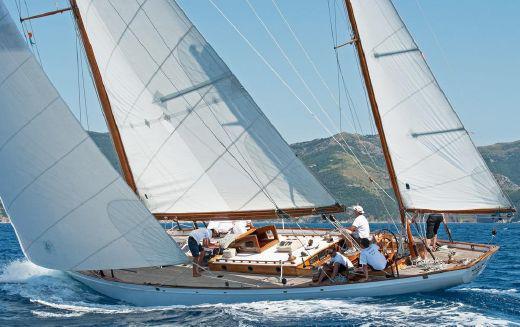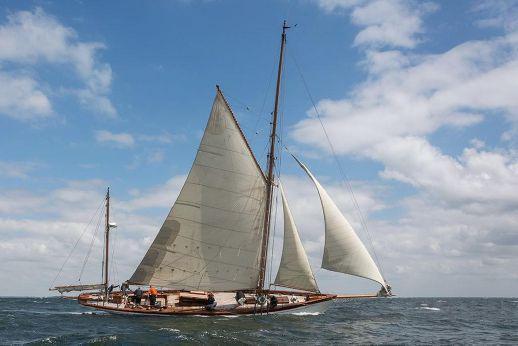The first image is the image on the left, the second image is the image on the right. Examine the images to the left and right. Is the description "The boat in the photo on the right is flying a flag off its rearmost line." accurate? Answer yes or no. No. The first image is the image on the left, the second image is the image on the right. Examine the images to the left and right. Is the description "There are exactly three inflated sails in the image on the right." accurate? Answer yes or no. Yes. 